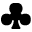<formula> <loc_0><loc_0><loc_500><loc_500>\clubsuit</formula> 